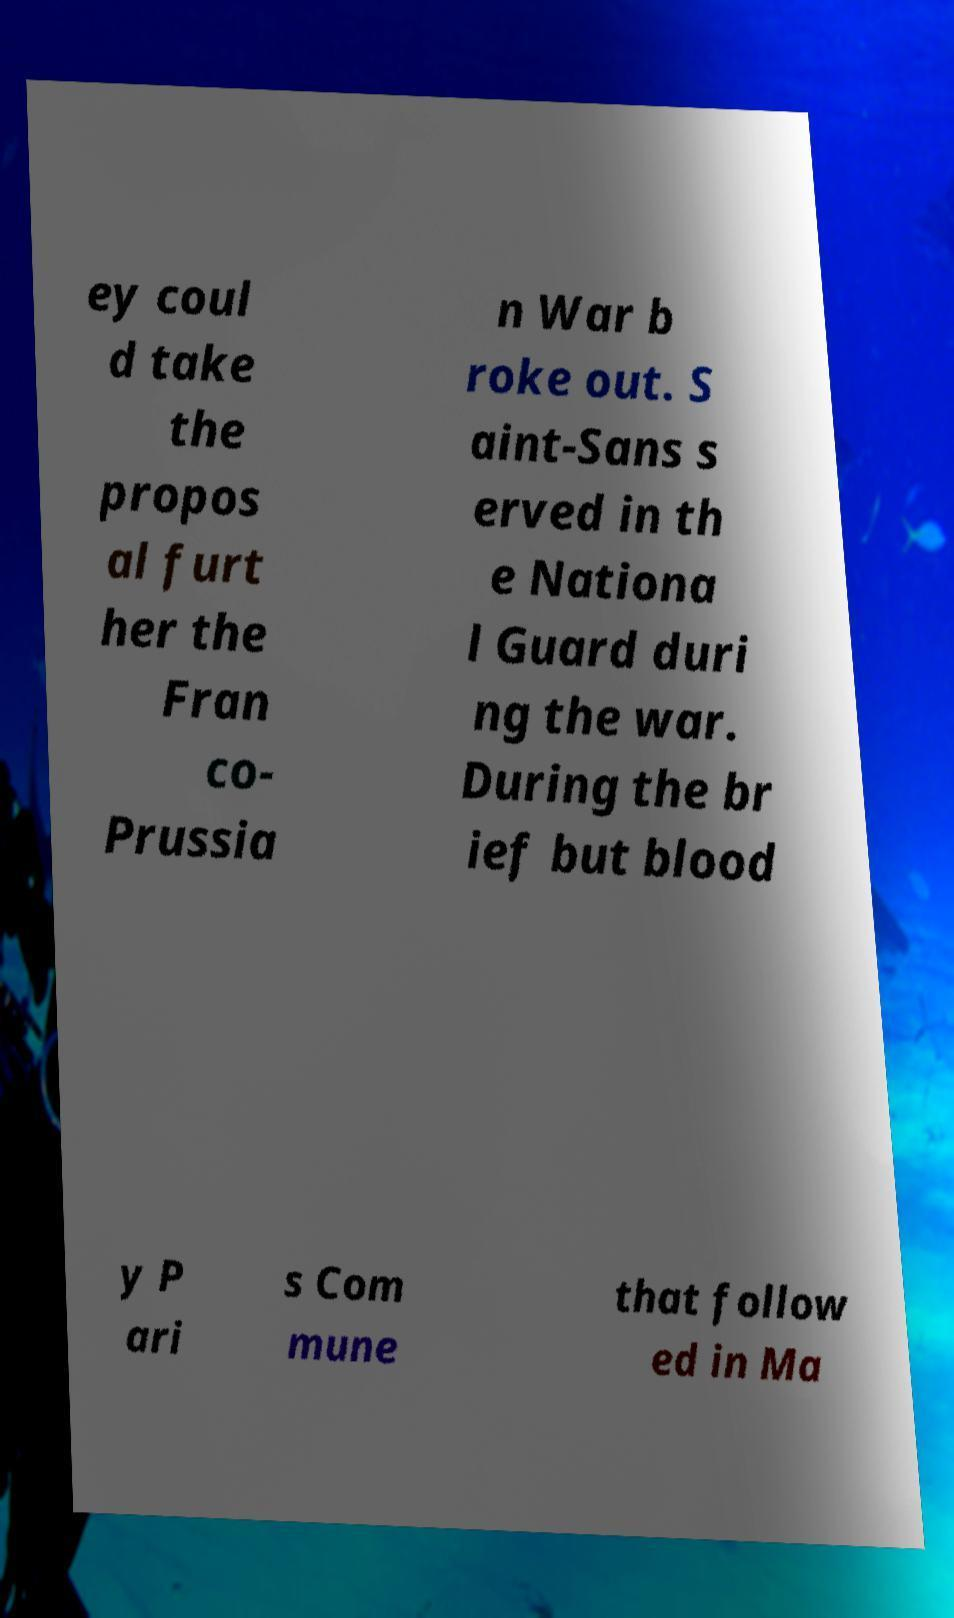Please identify and transcribe the text found in this image. ey coul d take the propos al furt her the Fran co- Prussia n War b roke out. S aint-Sans s erved in th e Nationa l Guard duri ng the war. During the br ief but blood y P ari s Com mune that follow ed in Ma 